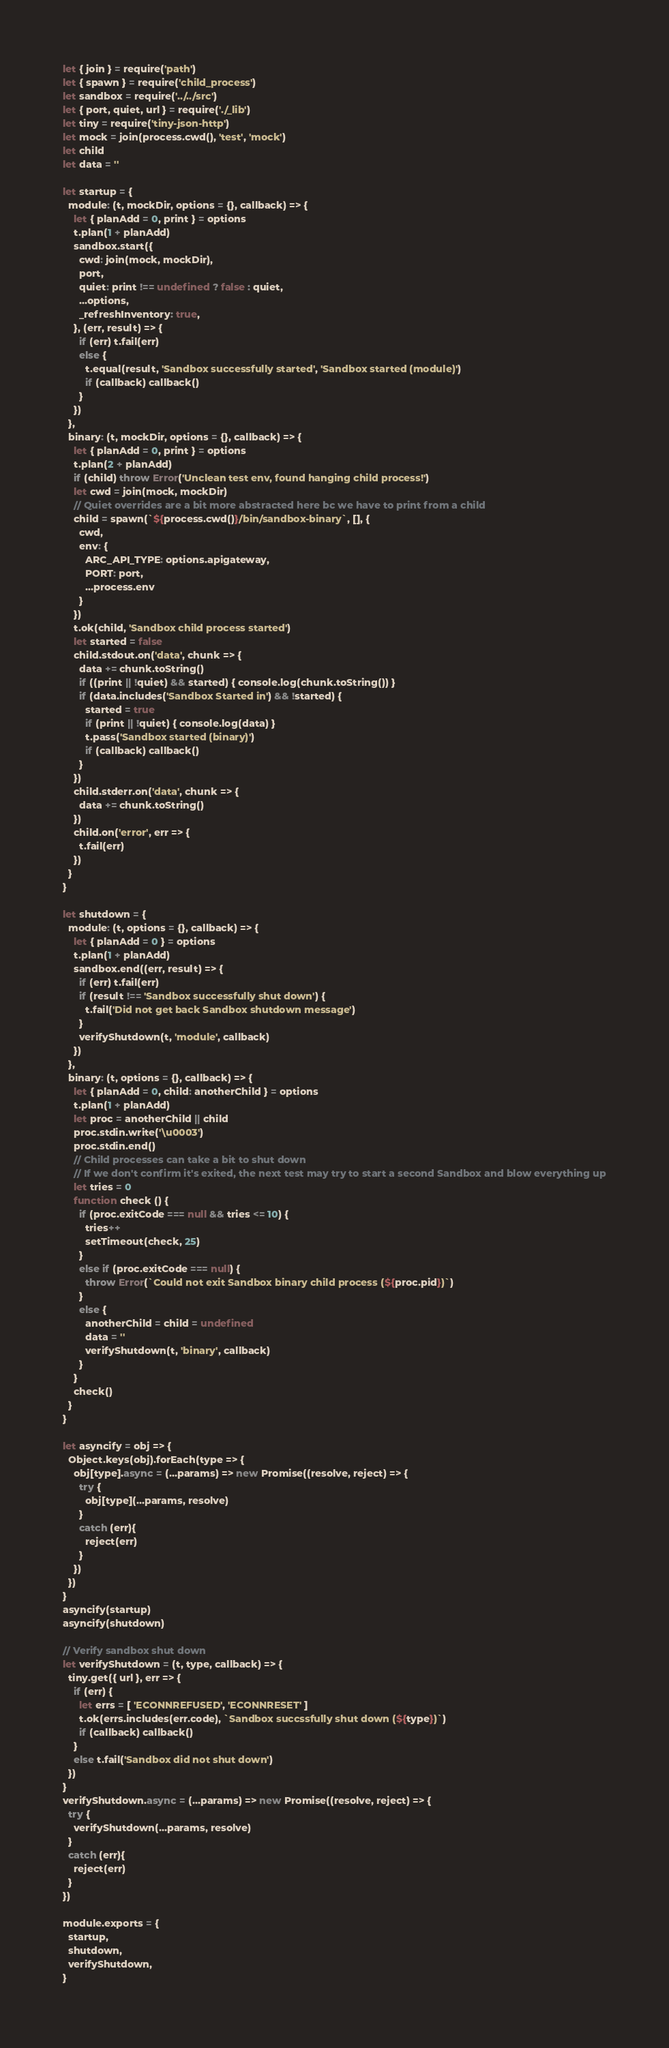<code> <loc_0><loc_0><loc_500><loc_500><_JavaScript_>let { join } = require('path')
let { spawn } = require('child_process')
let sandbox = require('../../src')
let { port, quiet, url } = require('./_lib')
let tiny = require('tiny-json-http')
let mock = join(process.cwd(), 'test', 'mock')
let child
let data = ''

let startup = {
  module: (t, mockDir, options = {}, callback) => {
    let { planAdd = 0, print } = options
    t.plan(1 + planAdd)
    sandbox.start({
      cwd: join(mock, mockDir),
      port,
      quiet: print !== undefined ? false : quiet,
      ...options,
      _refreshInventory: true,
    }, (err, result) => {
      if (err) t.fail(err)
      else {
        t.equal(result, 'Sandbox successfully started', 'Sandbox started (module)')
        if (callback) callback()
      }
    })
  },
  binary: (t, mockDir, options = {}, callback) => {
    let { planAdd = 0, print } = options
    t.plan(2 + planAdd)
    if (child) throw Error('Unclean test env, found hanging child process!')
    let cwd = join(mock, mockDir)
    // Quiet overrides are a bit more abstracted here bc we have to print from a child
    child = spawn(`${process.cwd()}/bin/sandbox-binary`, [], {
      cwd,
      env: {
        ARC_API_TYPE: options.apigateway,
        PORT: port,
        ...process.env
      }
    })
    t.ok(child, 'Sandbox child process started')
    let started = false
    child.stdout.on('data', chunk => {
      data += chunk.toString()
      if ((print || !quiet) && started) { console.log(chunk.toString()) }
      if (data.includes('Sandbox Started in') && !started) {
        started = true
        if (print || !quiet) { console.log(data) }
        t.pass('Sandbox started (binary)')
        if (callback) callback()
      }
    })
    child.stderr.on('data', chunk => {
      data += chunk.toString()
    })
    child.on('error', err => {
      t.fail(err)
    })
  }
}

let shutdown = {
  module: (t, options = {}, callback) => {
    let { planAdd = 0 } = options
    t.plan(1 + planAdd)
    sandbox.end((err, result) => {
      if (err) t.fail(err)
      if (result !== 'Sandbox successfully shut down') {
        t.fail('Did not get back Sandbox shutdown message')
      }
      verifyShutdown(t, 'module', callback)
    })
  },
  binary: (t, options = {}, callback) => {
    let { planAdd = 0, child: anotherChild } = options
    t.plan(1 + planAdd)
    let proc = anotherChild || child
    proc.stdin.write('\u0003')
    proc.stdin.end()
    // Child processes can take a bit to shut down
    // If we don't confirm it's exited, the next test may try to start a second Sandbox and blow everything up
    let tries = 0
    function check () {
      if (proc.exitCode === null && tries <= 10) {
        tries++
        setTimeout(check, 25)
      }
      else if (proc.exitCode === null) {
        throw Error(`Could not exit Sandbox binary child process (${proc.pid})`)
      }
      else {
        anotherChild = child = undefined
        data = ''
        verifyShutdown(t, 'binary', callback)
      }
    }
    check()
  }
}

let asyncify = obj => {
  Object.keys(obj).forEach(type => {
    obj[type].async = (...params) => new Promise((resolve, reject) => {
      try {
        obj[type](...params, resolve)
      }
      catch (err){
        reject(err)
      }
    })
  })
}
asyncify(startup)
asyncify(shutdown)

// Verify sandbox shut down
let verifyShutdown = (t, type, callback) => {
  tiny.get({ url }, err => {
    if (err) {
      let errs = [ 'ECONNREFUSED', 'ECONNRESET' ]
      t.ok(errs.includes(err.code), `Sandbox succssfully shut down (${type})`)
      if (callback) callback()
    }
    else t.fail('Sandbox did not shut down')
  })
}
verifyShutdown.async = (...params) => new Promise((resolve, reject) => {
  try {
    verifyShutdown(...params, resolve)
  }
  catch (err){
    reject(err)
  }
})

module.exports = {
  startup,
  shutdown,
  verifyShutdown,
}
</code> 